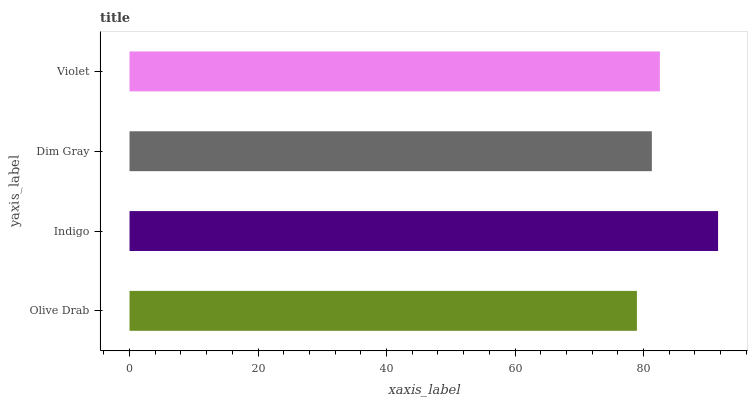Is Olive Drab the minimum?
Answer yes or no. Yes. Is Indigo the maximum?
Answer yes or no. Yes. Is Dim Gray the minimum?
Answer yes or no. No. Is Dim Gray the maximum?
Answer yes or no. No. Is Indigo greater than Dim Gray?
Answer yes or no. Yes. Is Dim Gray less than Indigo?
Answer yes or no. Yes. Is Dim Gray greater than Indigo?
Answer yes or no. No. Is Indigo less than Dim Gray?
Answer yes or no. No. Is Violet the high median?
Answer yes or no. Yes. Is Dim Gray the low median?
Answer yes or no. Yes. Is Dim Gray the high median?
Answer yes or no. No. Is Indigo the low median?
Answer yes or no. No. 